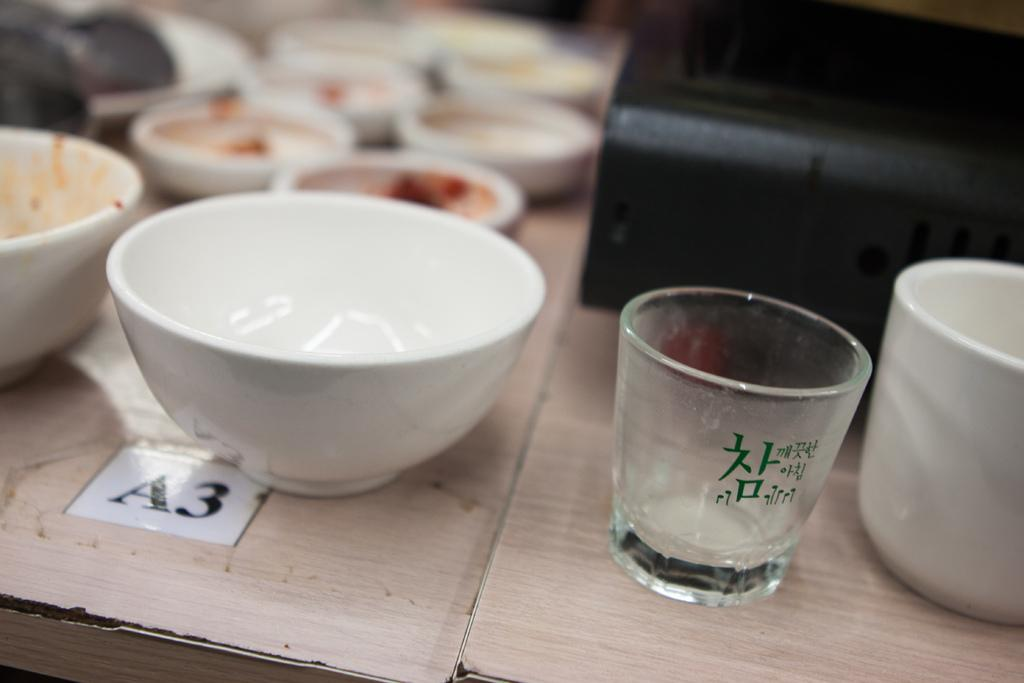What type of furniture is present at the bottom of the image? There are tables at the bottom of the image. What objects can be seen on the tables? There are bowls, glasses, cups, and a toaster on the tables. What might be used for holding liquids in the image? Glasses and cups are present on the tables for holding liquids. What type of spark can be seen coming from the toaster in the image? There is no spark visible in the image; the toaster is not shown in use. 